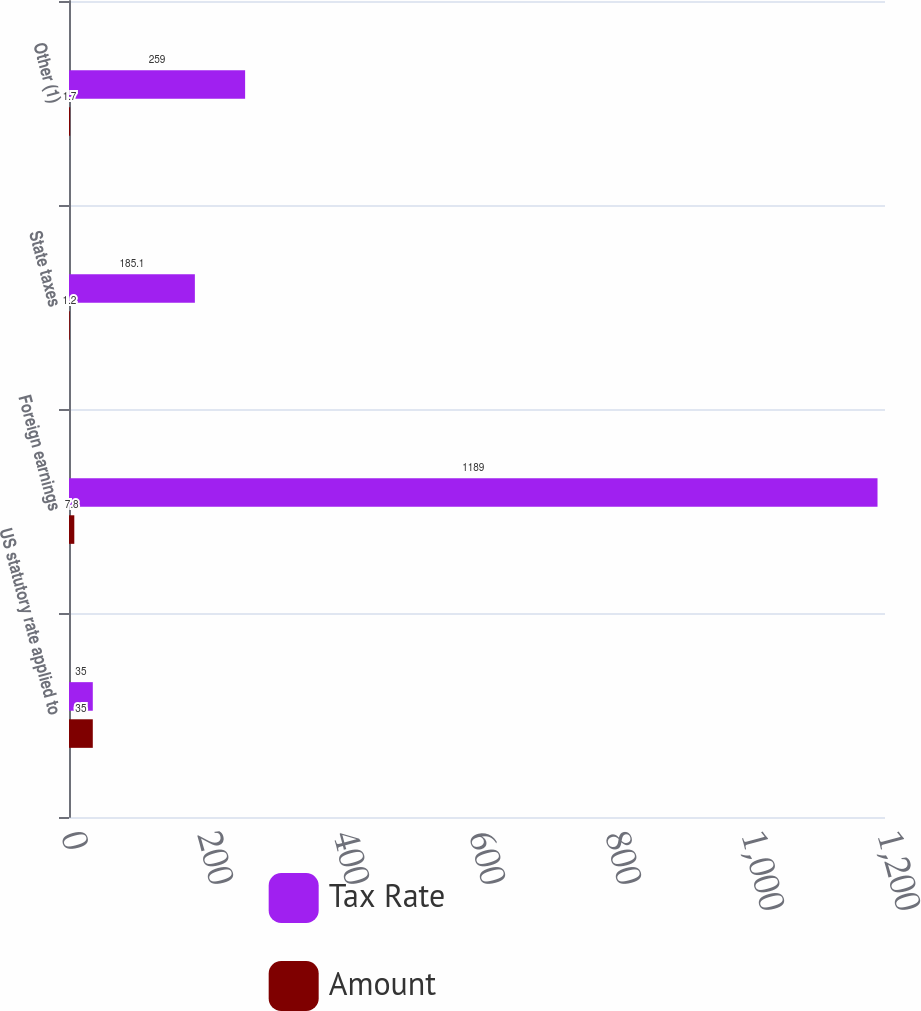<chart> <loc_0><loc_0><loc_500><loc_500><stacked_bar_chart><ecel><fcel>US statutory rate applied to<fcel>Foreign earnings<fcel>State taxes<fcel>Other (1)<nl><fcel>Tax Rate<fcel>35<fcel>1189<fcel>185.1<fcel>259<nl><fcel>Amount<fcel>35<fcel>7.8<fcel>1.2<fcel>1.7<nl></chart> 